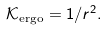Convert formula to latex. <formula><loc_0><loc_0><loc_500><loc_500>\mathcal { K } _ { \text {ergo} } = 1 / r ^ { 2 } .</formula> 